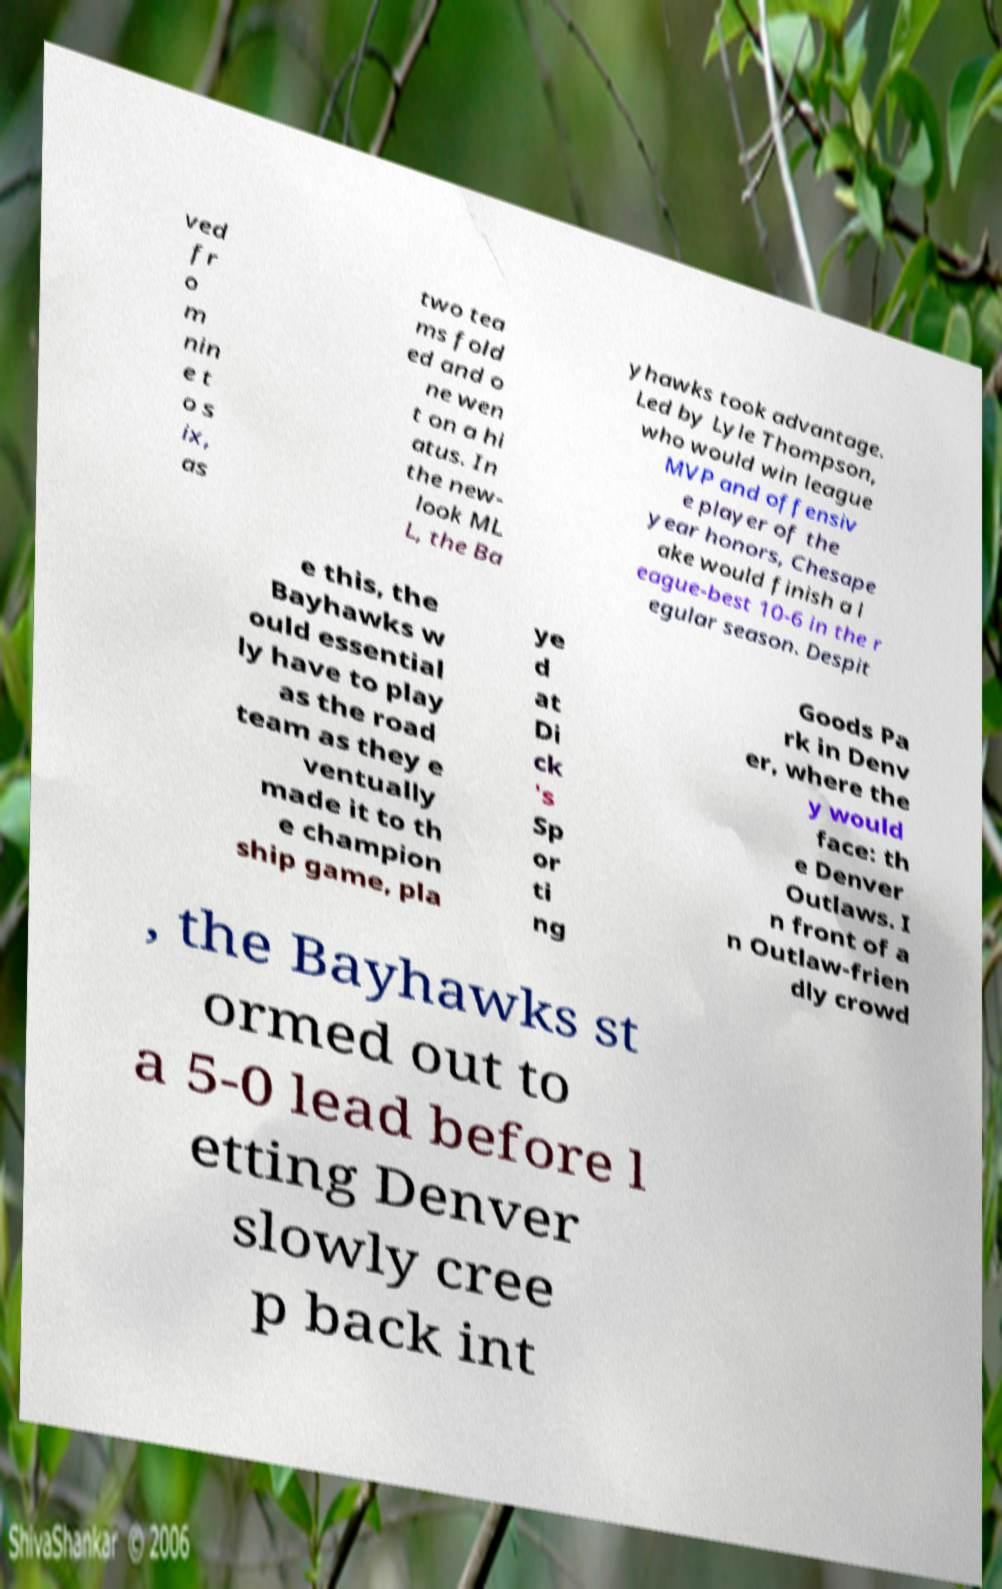For documentation purposes, I need the text within this image transcribed. Could you provide that? ved fr o m nin e t o s ix, as two tea ms fold ed and o ne wen t on a hi atus. In the new- look ML L, the Ba yhawks took advantage. Led by Lyle Thompson, who would win league MVP and offensiv e player of the year honors, Chesape ake would finish a l eague-best 10-6 in the r egular season. Despit e this, the Bayhawks w ould essential ly have to play as the road team as they e ventually made it to th e champion ship game, pla ye d at Di ck 's Sp or ti ng Goods Pa rk in Denv er, where the y would face: th e Denver Outlaws. I n front of a n Outlaw-frien dly crowd , the Bayhawks st ormed out to a 5-0 lead before l etting Denver slowly cree p back int 